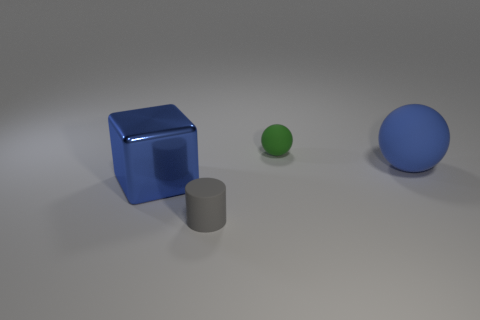How many things are the same size as the blue block?
Offer a very short reply. 1. There is a matte object that is in front of the small green object and right of the gray thing; what is its color?
Make the answer very short. Blue. Is the number of blue balls to the right of the green thing greater than the number of yellow things?
Your answer should be compact. Yes. Are any blue objects visible?
Your answer should be compact. Yes. Does the shiny object have the same color as the large rubber object?
Your answer should be very brief. Yes. How many small objects are blocks or gray objects?
Provide a succinct answer. 1. Is there any other thing of the same color as the cylinder?
Offer a terse response. No. The tiny green object that is made of the same material as the blue sphere is what shape?
Your answer should be compact. Sphere. There is a matte object that is left of the tiny rubber sphere; how big is it?
Your response must be concise. Small. What is the shape of the green thing?
Your answer should be compact. Sphere. 